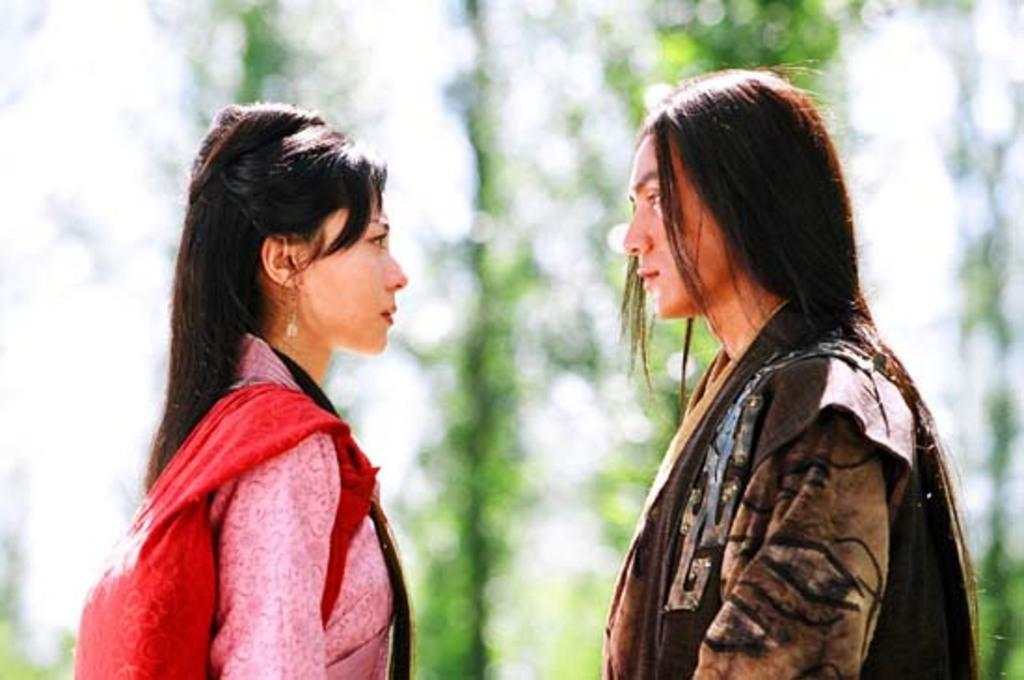How many people are in the image? There are two persons in the image. What colors are the dresses worn by the persons? One person is wearing a pink dress, and the other person is wearing a brown dress. Can you describe the background of the image? The background of the image is blurry. What type of eggnog is being served at the event in the image? There is no event or eggnog present in the image; it features two persons wearing dresses with a blurry background. 